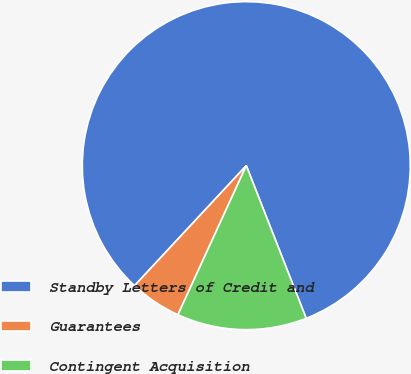Convert chart to OTSL. <chart><loc_0><loc_0><loc_500><loc_500><pie_chart><fcel>Standby Letters of Credit and<fcel>Guarantees<fcel>Contingent Acquisition<nl><fcel>82.12%<fcel>5.09%<fcel>12.79%<nl></chart> 